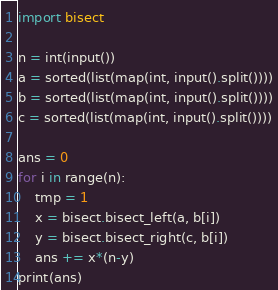Convert code to text. <code><loc_0><loc_0><loc_500><loc_500><_Python_>import bisect

n = int(input())
a = sorted(list(map(int, input().split())))
b = sorted(list(map(int, input().split())))
c = sorted(list(map(int, input().split())))

ans = 0
for i in range(n):
    tmp = 1
    x = bisect.bisect_left(a, b[i])
    y = bisect.bisect_right(c, b[i])
    ans += x*(n-y)
print(ans)</code> 